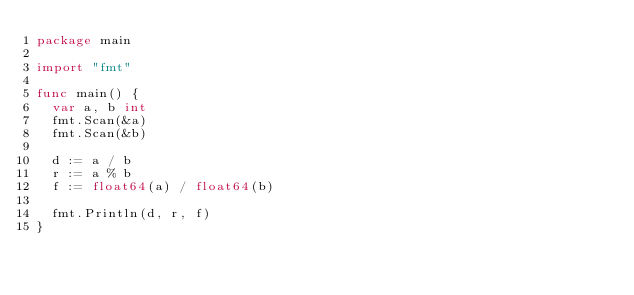<code> <loc_0><loc_0><loc_500><loc_500><_Go_>package main

import "fmt"

func main() {
	var a, b int
	fmt.Scan(&a)
	fmt.Scan(&b)

	d := a / b
	r := a % b
	f := float64(a) / float64(b)

	fmt.Println(d, r, f)
}

</code> 